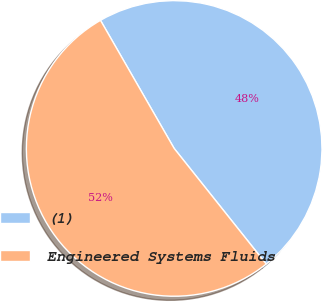Convert chart. <chart><loc_0><loc_0><loc_500><loc_500><pie_chart><fcel>(1)<fcel>Engineered Systems Fluids<nl><fcel>47.6%<fcel>52.4%<nl></chart> 